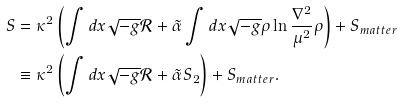<formula> <loc_0><loc_0><loc_500><loc_500>S & = \kappa ^ { 2 } \left ( \int d x \sqrt { - g } { \mathcal { R } } + \tilde { \alpha } \int d x \sqrt { - g } \rho \ln \frac { \nabla ^ { 2 } } { \mu ^ { 2 } } \rho \right ) + S _ { m a t t e r } \\ & \equiv \kappa ^ { 2 } \left ( \int d x \sqrt { - g } { \mathcal { R } } + \tilde { \alpha } S _ { 2 } \right ) + S _ { m a t t e r } .</formula> 